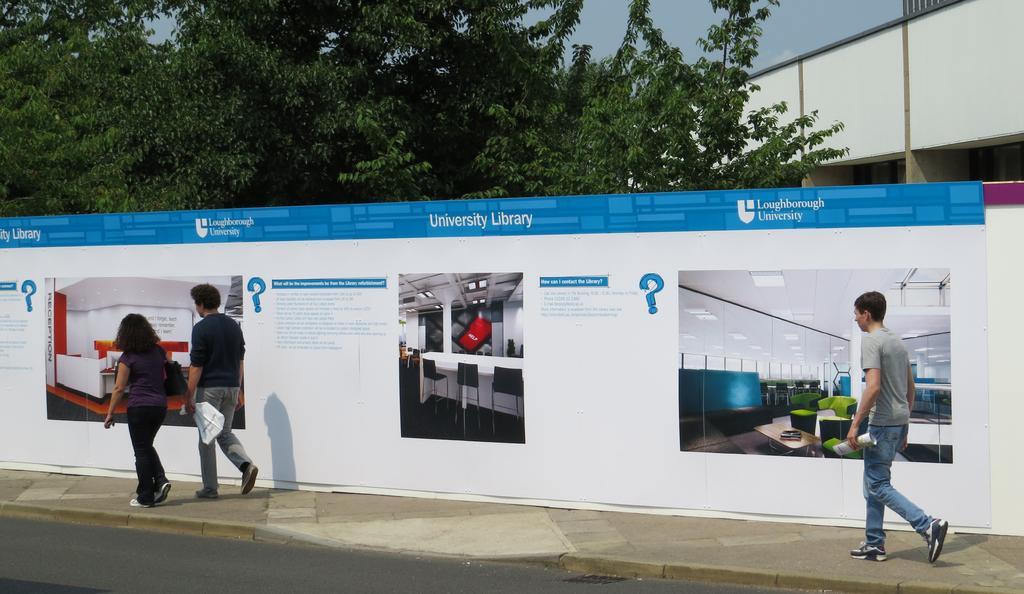Describe this image in one or two sentences. In this image I can see the road, few persons standing on the sidewalk and a huge banner which is white and blue in color. In the background I can see few trees which are green in color, a bridge and the sky. 